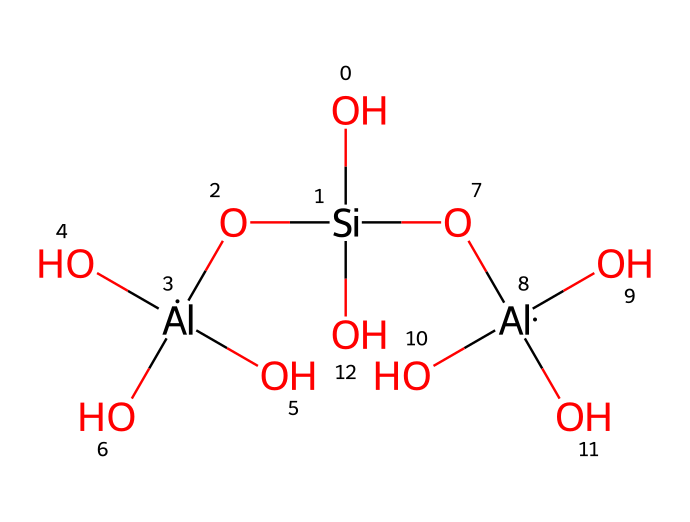What is the main component of the chemical depicted? The chemical contains silicon and aluminum, which suggests that clay primarily consists of these two elements.
Answer: silicon How many aluminum atoms are present in the structure? By analyzing the SMILES representation, we can count that there are three aluminum atoms in the structural formula.
Answer: three What type of material does this chemical represent? The chemical structure contains silicates and alumino-silicates, which are characteristic of ceramic materials, specifically clays.
Answer: ceramic What is the primary bonding type in clay? The structure indicates that both silicon and aluminum atoms are connected with oxygen, showcasing covalent bonding as the primary type.
Answer: covalent How would you describe the overall charge of the molecule? The presence of aluminum oxides and silicates suggests the structure has a neutral charge overall, as it constitutes typical clay components.
Answer: neutral 